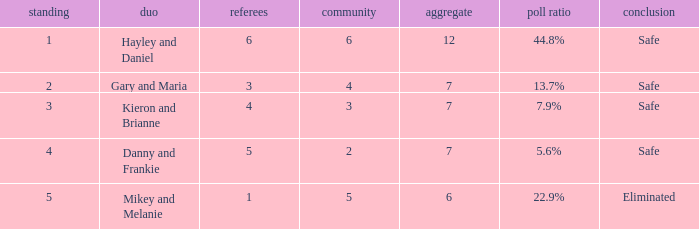What was the result for the total of 12? Safe. 